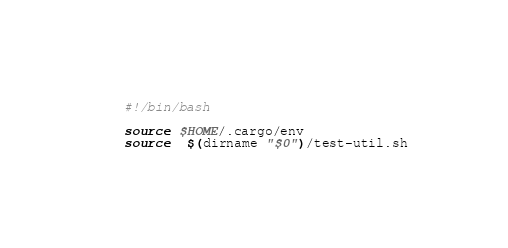<code> <loc_0><loc_0><loc_500><loc_500><_Bash_>#!/bin/bash

source $HOME/.cargo/env
source  $(dirname "$0")/test-util.sh
</code> 